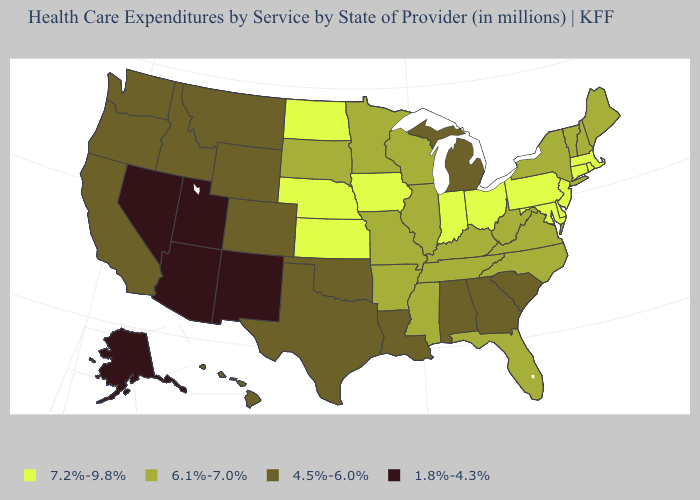Name the states that have a value in the range 4.5%-6.0%?
Quick response, please. Alabama, California, Colorado, Georgia, Hawaii, Idaho, Louisiana, Michigan, Montana, Oklahoma, Oregon, South Carolina, Texas, Washington, Wyoming. What is the lowest value in states that border Michigan?
Be succinct. 6.1%-7.0%. How many symbols are there in the legend?
Give a very brief answer. 4. What is the value of Montana?
Write a very short answer. 4.5%-6.0%. What is the lowest value in the West?
Answer briefly. 1.8%-4.3%. Which states have the lowest value in the West?
Keep it brief. Alaska, Arizona, Nevada, New Mexico, Utah. What is the value of Arkansas?
Quick response, please. 6.1%-7.0%. Which states have the lowest value in the Northeast?
Quick response, please. Maine, New Hampshire, New York, Vermont. Among the states that border Kentucky , does Missouri have the lowest value?
Answer briefly. Yes. Name the states that have a value in the range 7.2%-9.8%?
Write a very short answer. Connecticut, Delaware, Indiana, Iowa, Kansas, Maryland, Massachusetts, Nebraska, New Jersey, North Dakota, Ohio, Pennsylvania, Rhode Island. Does Minnesota have the same value as Wyoming?
Concise answer only. No. Does the map have missing data?
Give a very brief answer. No. What is the value of South Dakota?
Keep it brief. 6.1%-7.0%. Does Alabama have the lowest value in the South?
Be succinct. Yes. Name the states that have a value in the range 1.8%-4.3%?
Answer briefly. Alaska, Arizona, Nevada, New Mexico, Utah. 